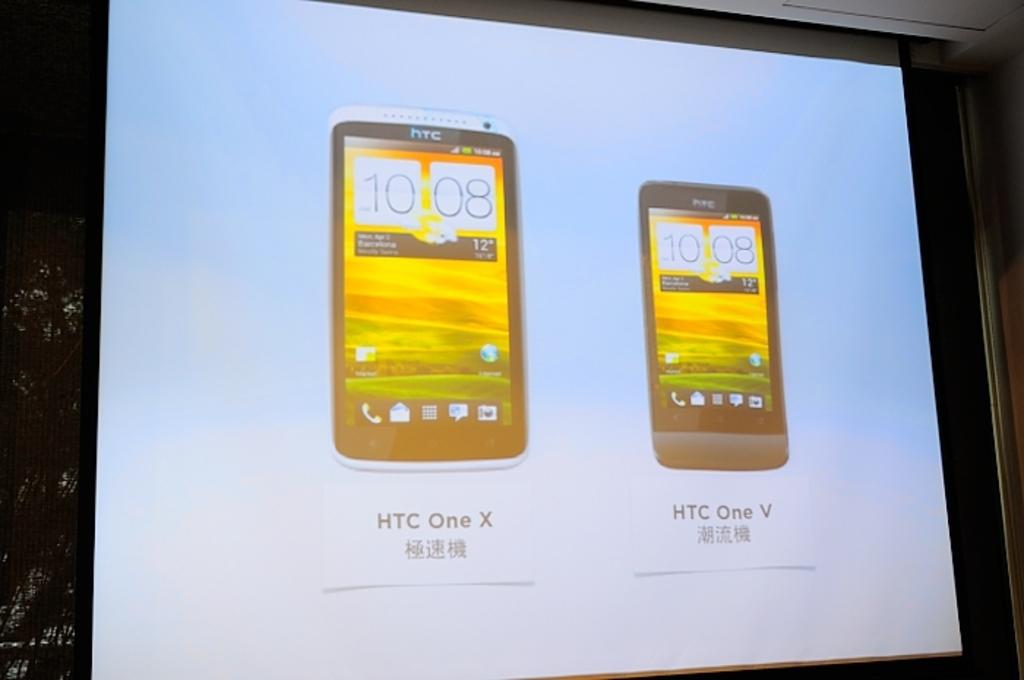<image>
Relay a brief, clear account of the picture shown. an advertisement for the htc one x and htc one v 